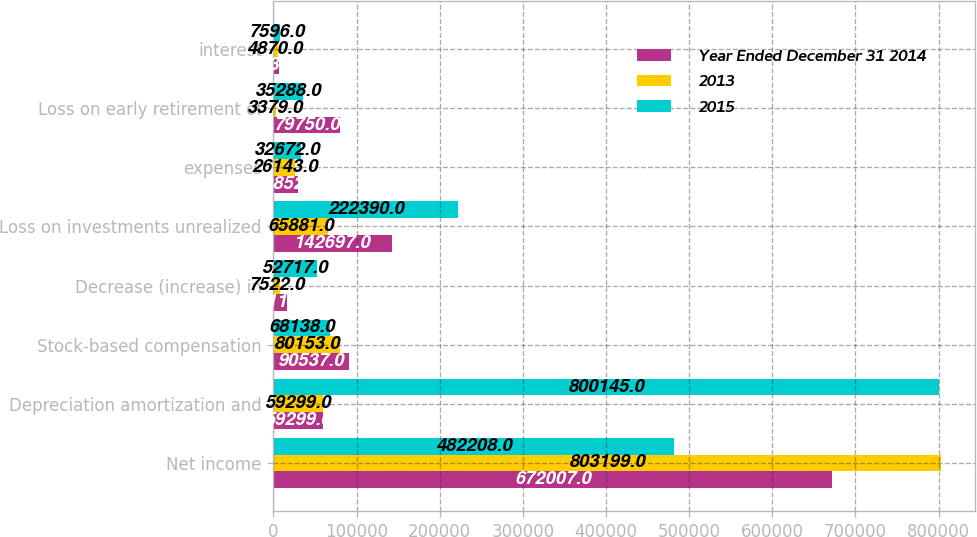Convert chart. <chart><loc_0><loc_0><loc_500><loc_500><stacked_bar_chart><ecel><fcel>Net income<fcel>Depreciation amortization and<fcel>Stock-based compensation<fcel>Decrease (increase) in<fcel>Loss on investments unrealized<fcel>expenses<fcel>Loss on early retirement of<fcel>interest<nl><fcel>Year Ended December 31 2014<fcel>672007<fcel>59299<fcel>90537<fcel>16112<fcel>142697<fcel>29852<fcel>79750<fcel>6932<nl><fcel>2013<fcel>803199<fcel>59299<fcel>80153<fcel>7522<fcel>65881<fcel>26143<fcel>3379<fcel>4870<nl><fcel>2015<fcel>482208<fcel>800145<fcel>68138<fcel>52717<fcel>222390<fcel>32672<fcel>35288<fcel>7596<nl></chart> 